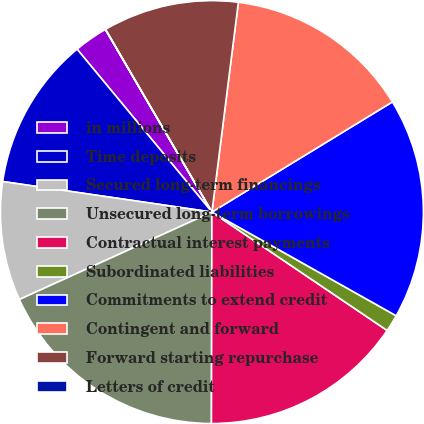Convert chart. <chart><loc_0><loc_0><loc_500><loc_500><pie_chart><fcel>in millions<fcel>Time deposits<fcel>Secured long-term financings<fcel>Unsecured long-term borrowings<fcel>Contractual interest payments<fcel>Subordinated liabilities<fcel>Commitments to extend credit<fcel>Contingent and forward<fcel>Forward starting repurchase<fcel>Letters of credit<nl><fcel>2.6%<fcel>11.69%<fcel>9.09%<fcel>18.18%<fcel>15.58%<fcel>1.3%<fcel>16.88%<fcel>14.28%<fcel>10.39%<fcel>0.01%<nl></chart> 